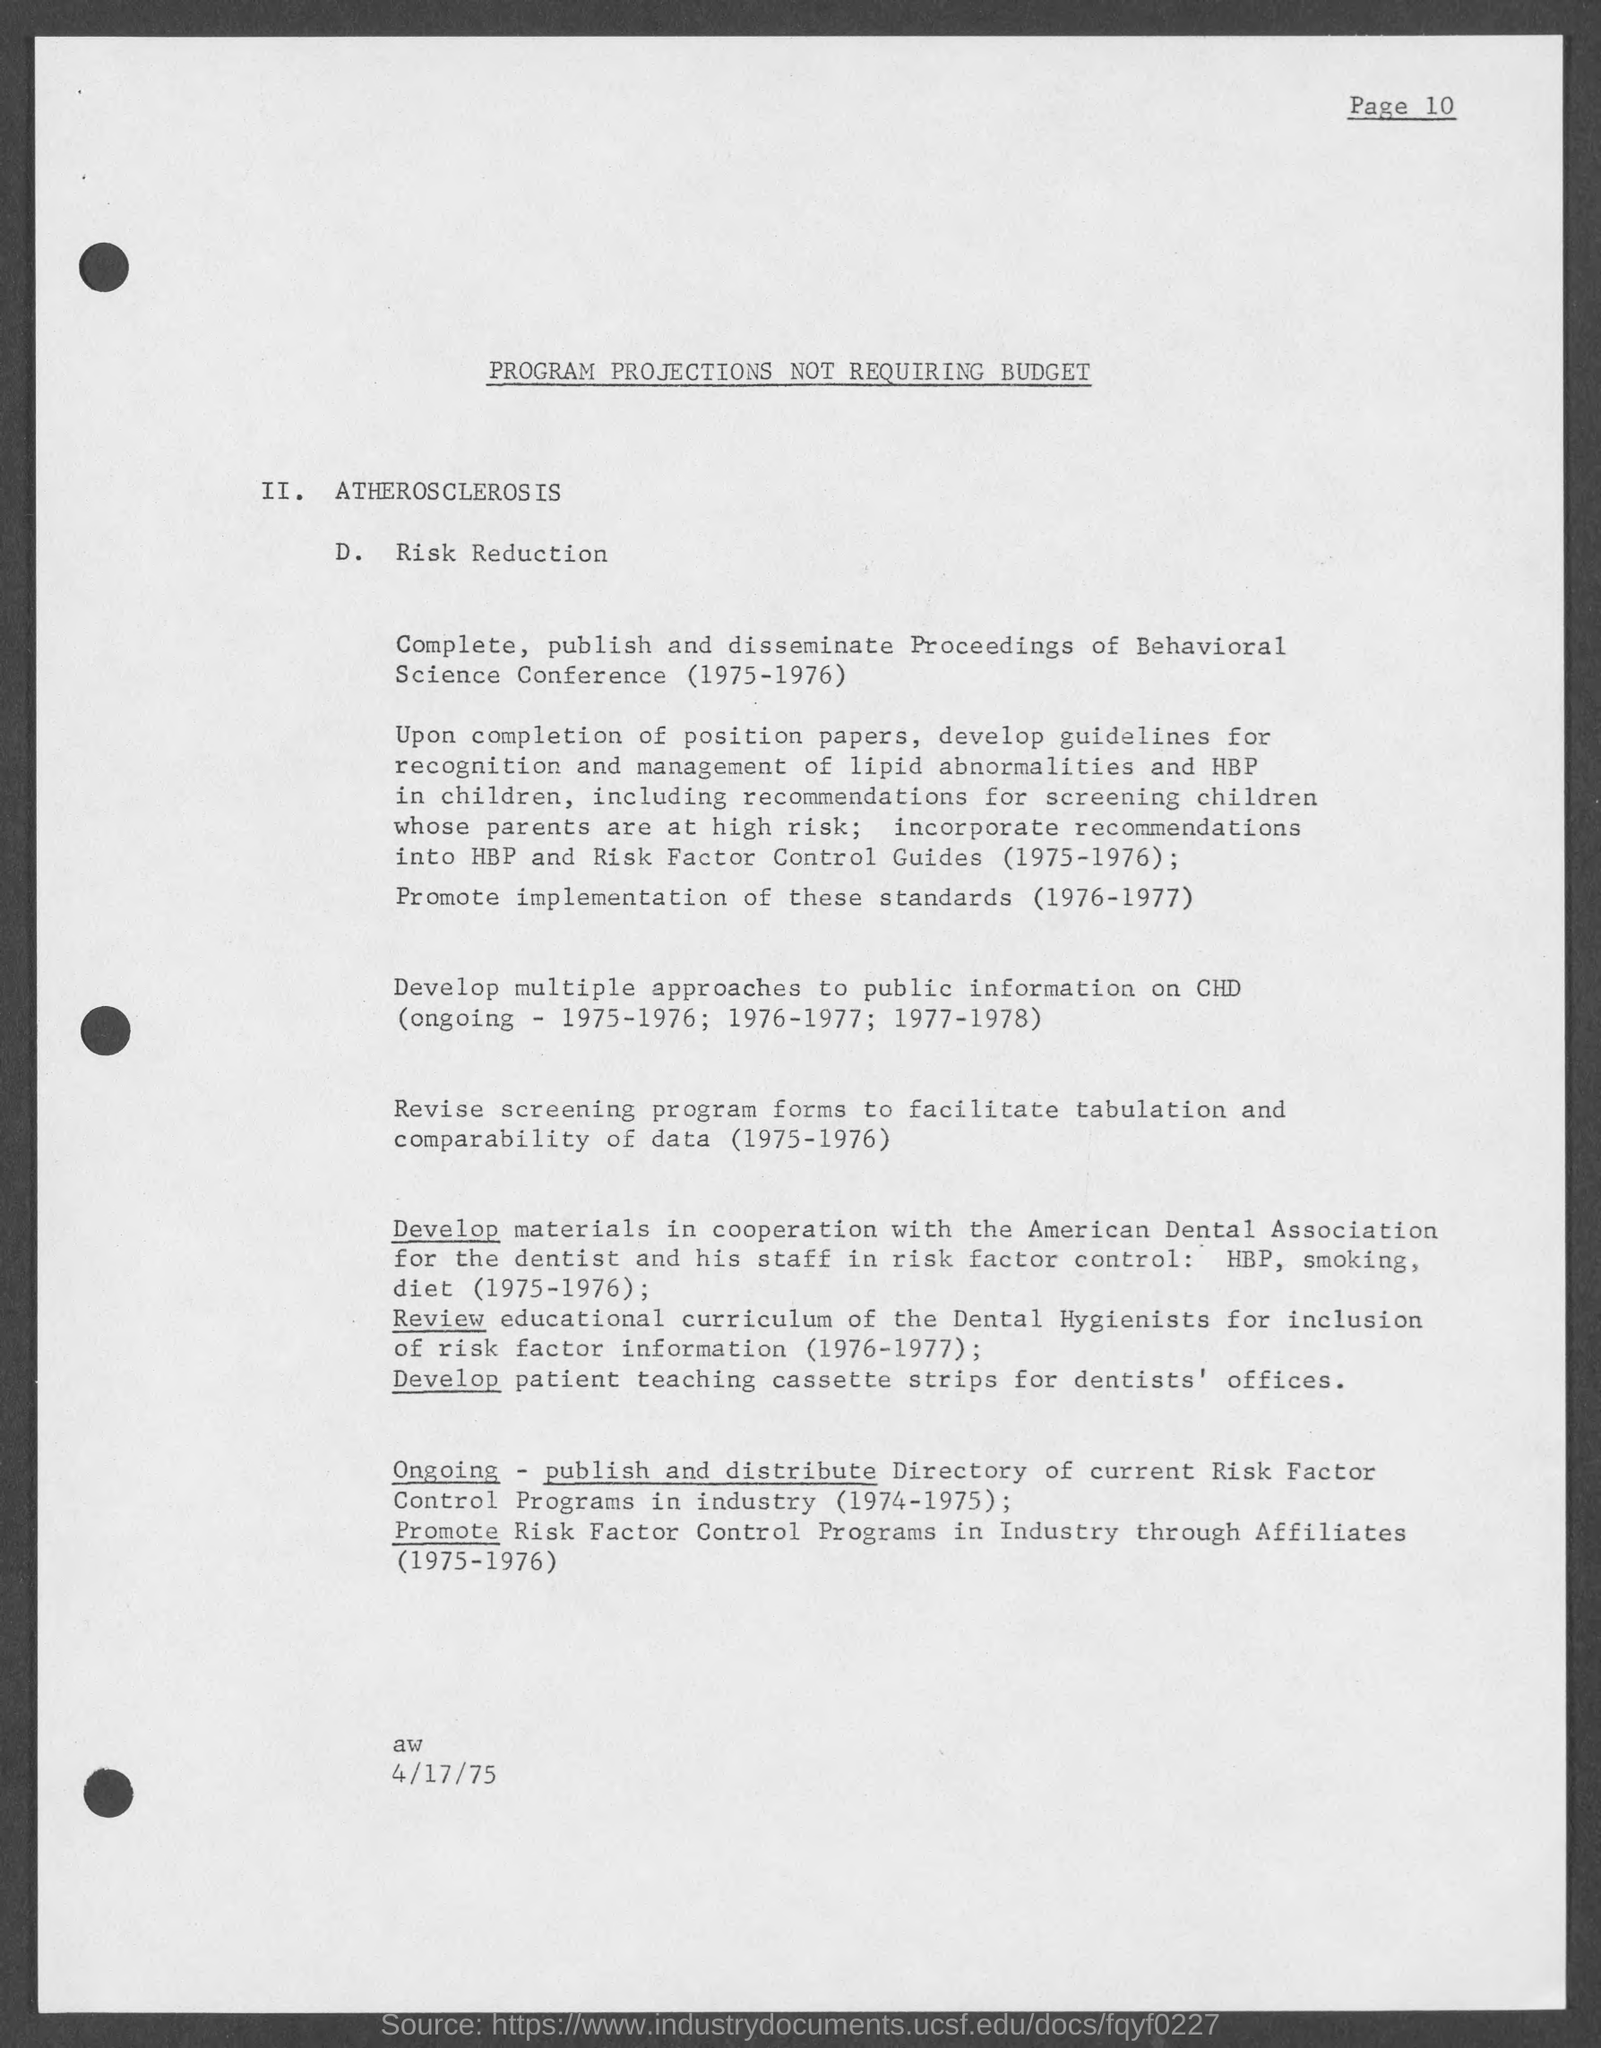What is the main heading of the document?
Your answer should be compact. PROGRAM PROJECTIONS NOT REQUIRING BUDGET. What is the date mentioned in this document?
Offer a terse response. 4/17/75. 